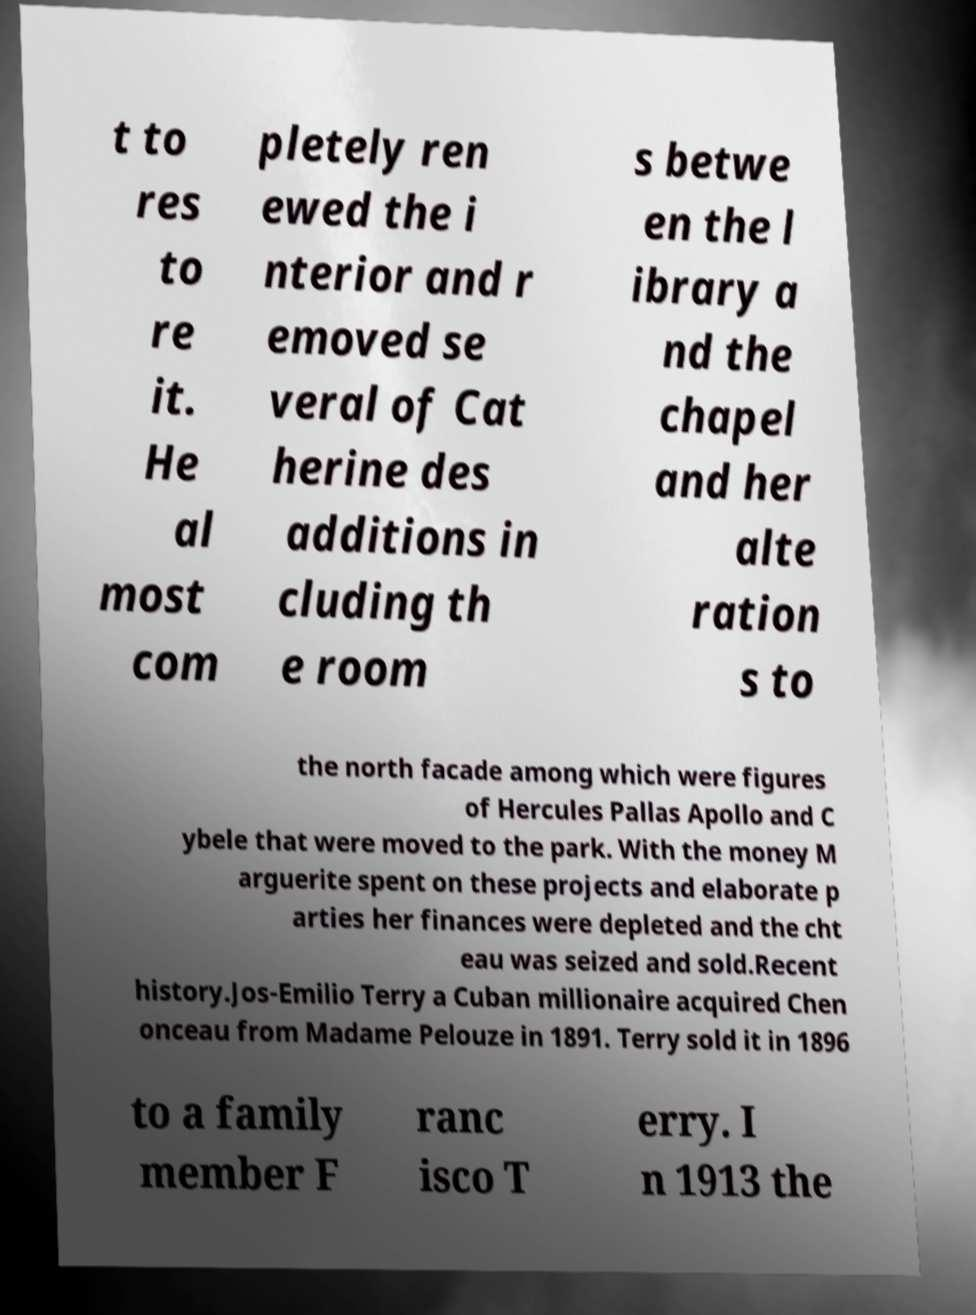Can you accurately transcribe the text from the provided image for me? t to res to re it. He al most com pletely ren ewed the i nterior and r emoved se veral of Cat herine des additions in cluding th e room s betwe en the l ibrary a nd the chapel and her alte ration s to the north facade among which were figures of Hercules Pallas Apollo and C ybele that were moved to the park. With the money M arguerite spent on these projects and elaborate p arties her finances were depleted and the cht eau was seized and sold.Recent history.Jos-Emilio Terry a Cuban millionaire acquired Chen onceau from Madame Pelouze in 1891. Terry sold it in 1896 to a family member F ranc isco T erry. I n 1913 the 